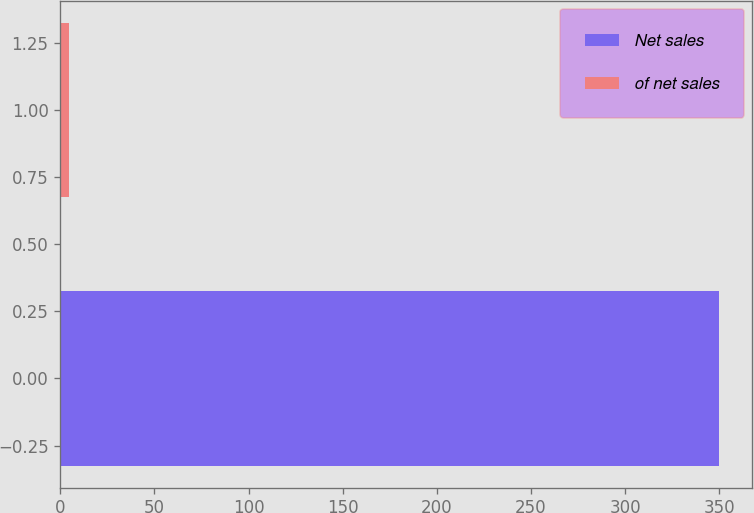Convert chart. <chart><loc_0><loc_0><loc_500><loc_500><bar_chart><fcel>Net sales<fcel>of net sales<nl><fcel>350.1<fcel>4.7<nl></chart> 